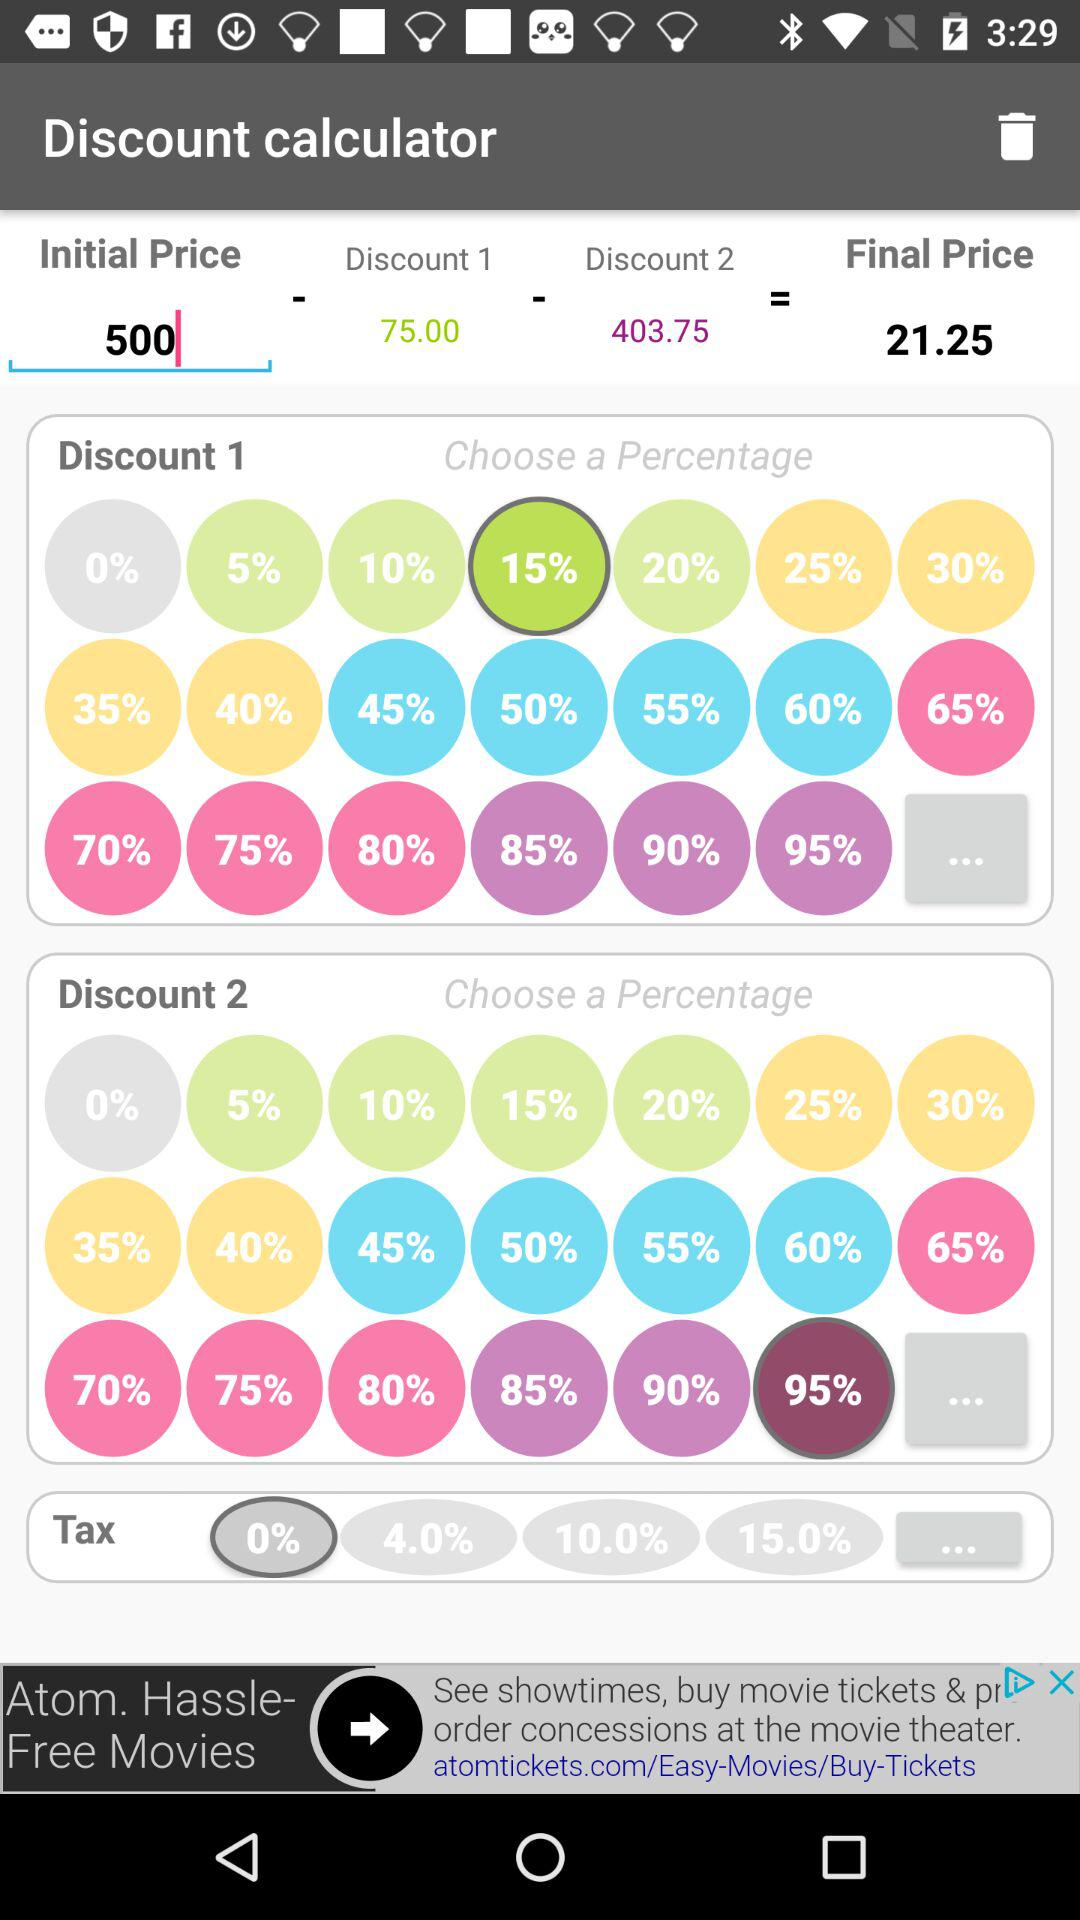Which percentage is selected in "Discount 1"? The selected percentage is 15. 